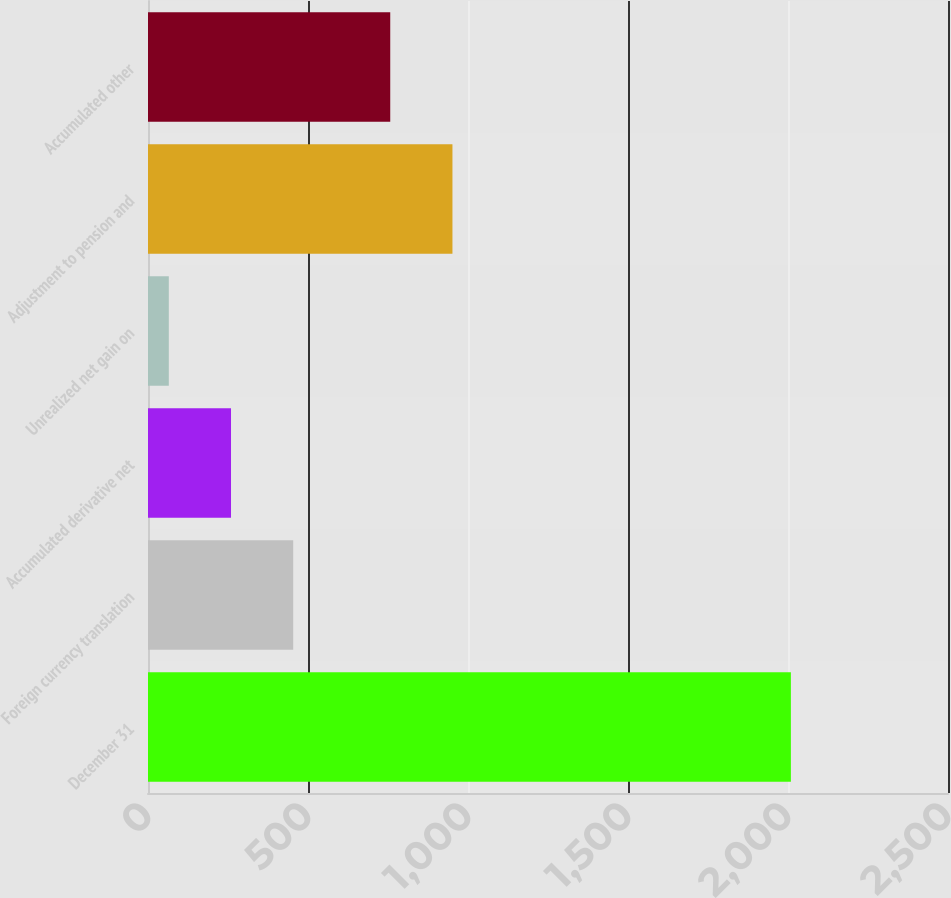<chart> <loc_0><loc_0><loc_500><loc_500><bar_chart><fcel>December 31<fcel>Foreign currency translation<fcel>Accumulated derivative net<fcel>Unrealized net gain on<fcel>Adjustment to pension and<fcel>Accumulated other<nl><fcel>2009<fcel>453.8<fcel>259.4<fcel>65<fcel>951.4<fcel>757<nl></chart> 